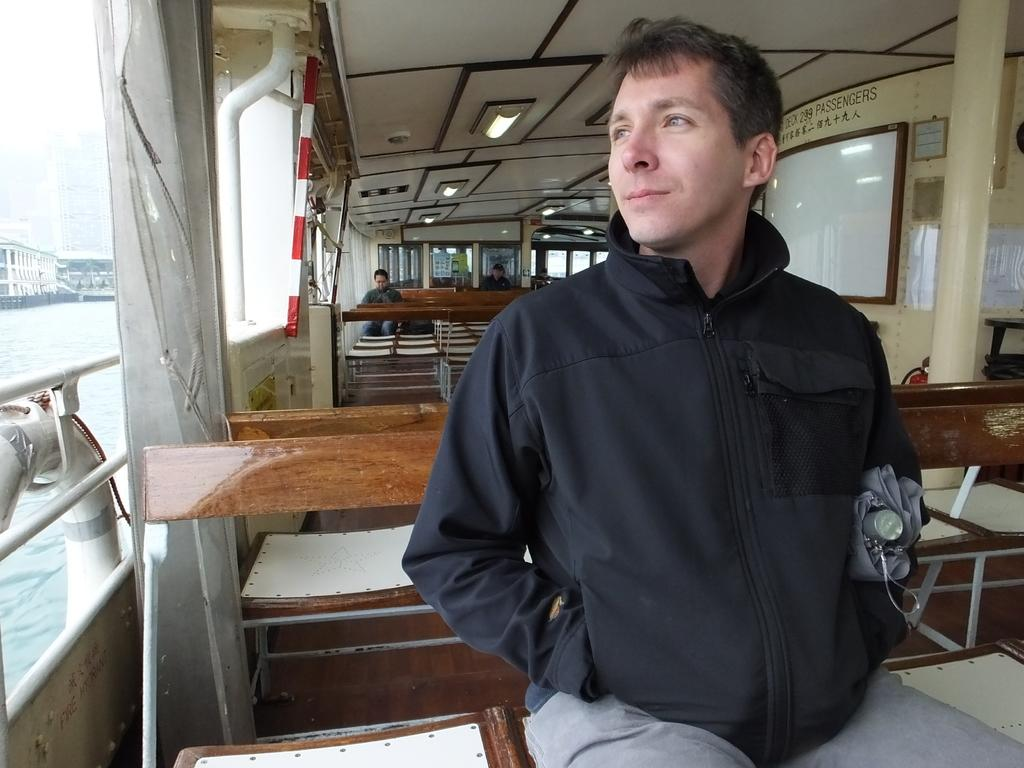Where is the image taken? The image is taken inside a boat. What can be seen inside the boat? There is a person sitting in the boat. What is the person wearing? The person is wearing a jacket. What is visible to the left side of the image? We start by identifying the location of the image, which is inside a boat. Then, we describe the person and their clothing, as well as the presence of buildings and water in the image. Each question is designed to elicit a specific detail about the image that is known from the provided facts. Absurd Question/Answer: What type of root can be seen growing near the person in the image? There is no root visible in the image; it is taken inside a boat with water and buildings in the background. How many ducks are swimming in the water near the person in the image? There are no ducks visible in the image; it is taken inside a boat with water and buildings in the background. 